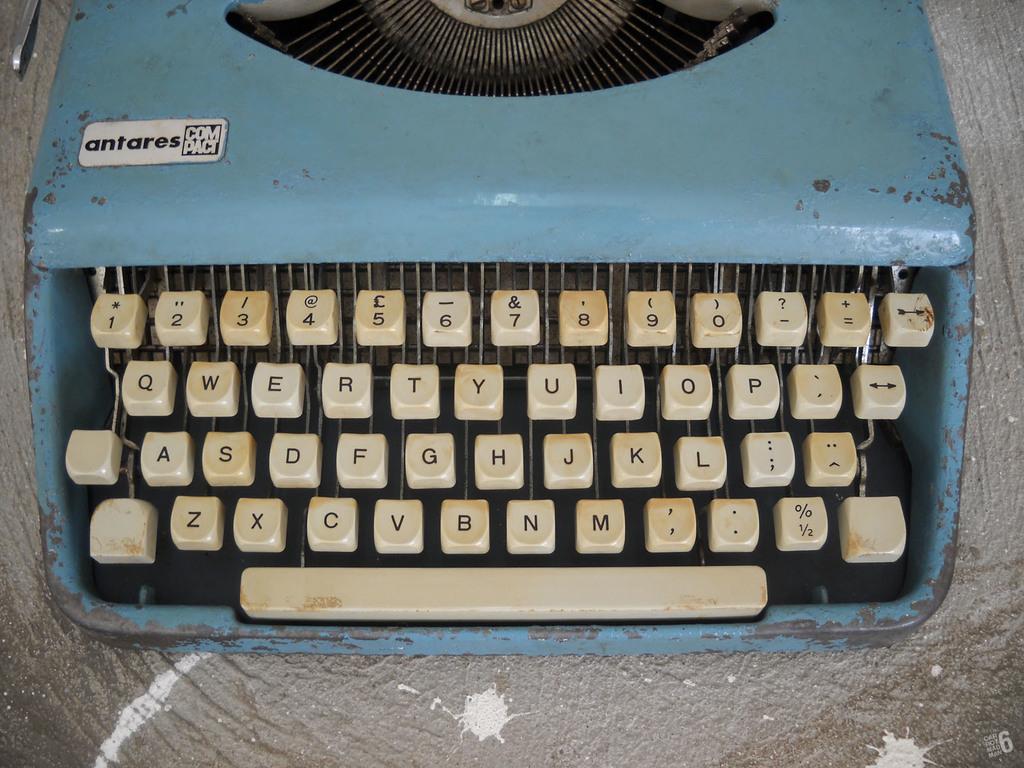What brand is this typewriter?
Keep it short and to the point. Antares. What is the key on the top left corner?
Keep it short and to the point. 1. 